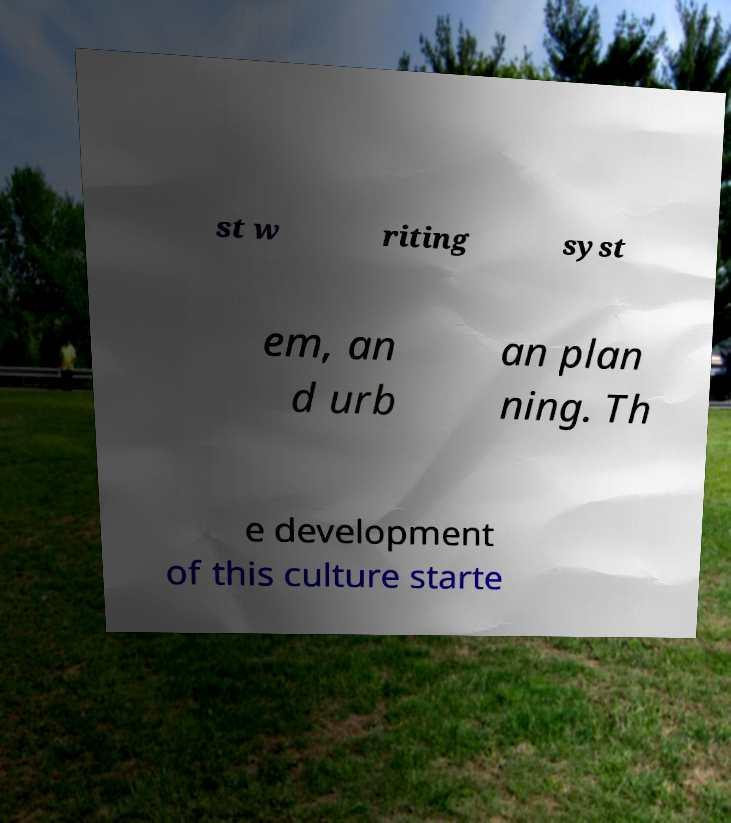Can you read and provide the text displayed in the image?This photo seems to have some interesting text. Can you extract and type it out for me? st w riting syst em, an d urb an plan ning. Th e development of this culture starte 